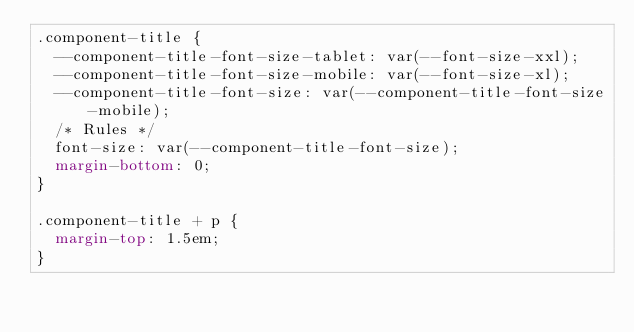Convert code to text. <code><loc_0><loc_0><loc_500><loc_500><_CSS_>.component-title {
  --component-title-font-size-tablet: var(--font-size-xxl);
  --component-title-font-size-mobile: var(--font-size-xl);
  --component-title-font-size: var(--component-title-font-size-mobile);
  /* Rules */
  font-size: var(--component-title-font-size);
  margin-bottom: 0;
}

.component-title + p {
  margin-top: 1.5em;
}
</code> 